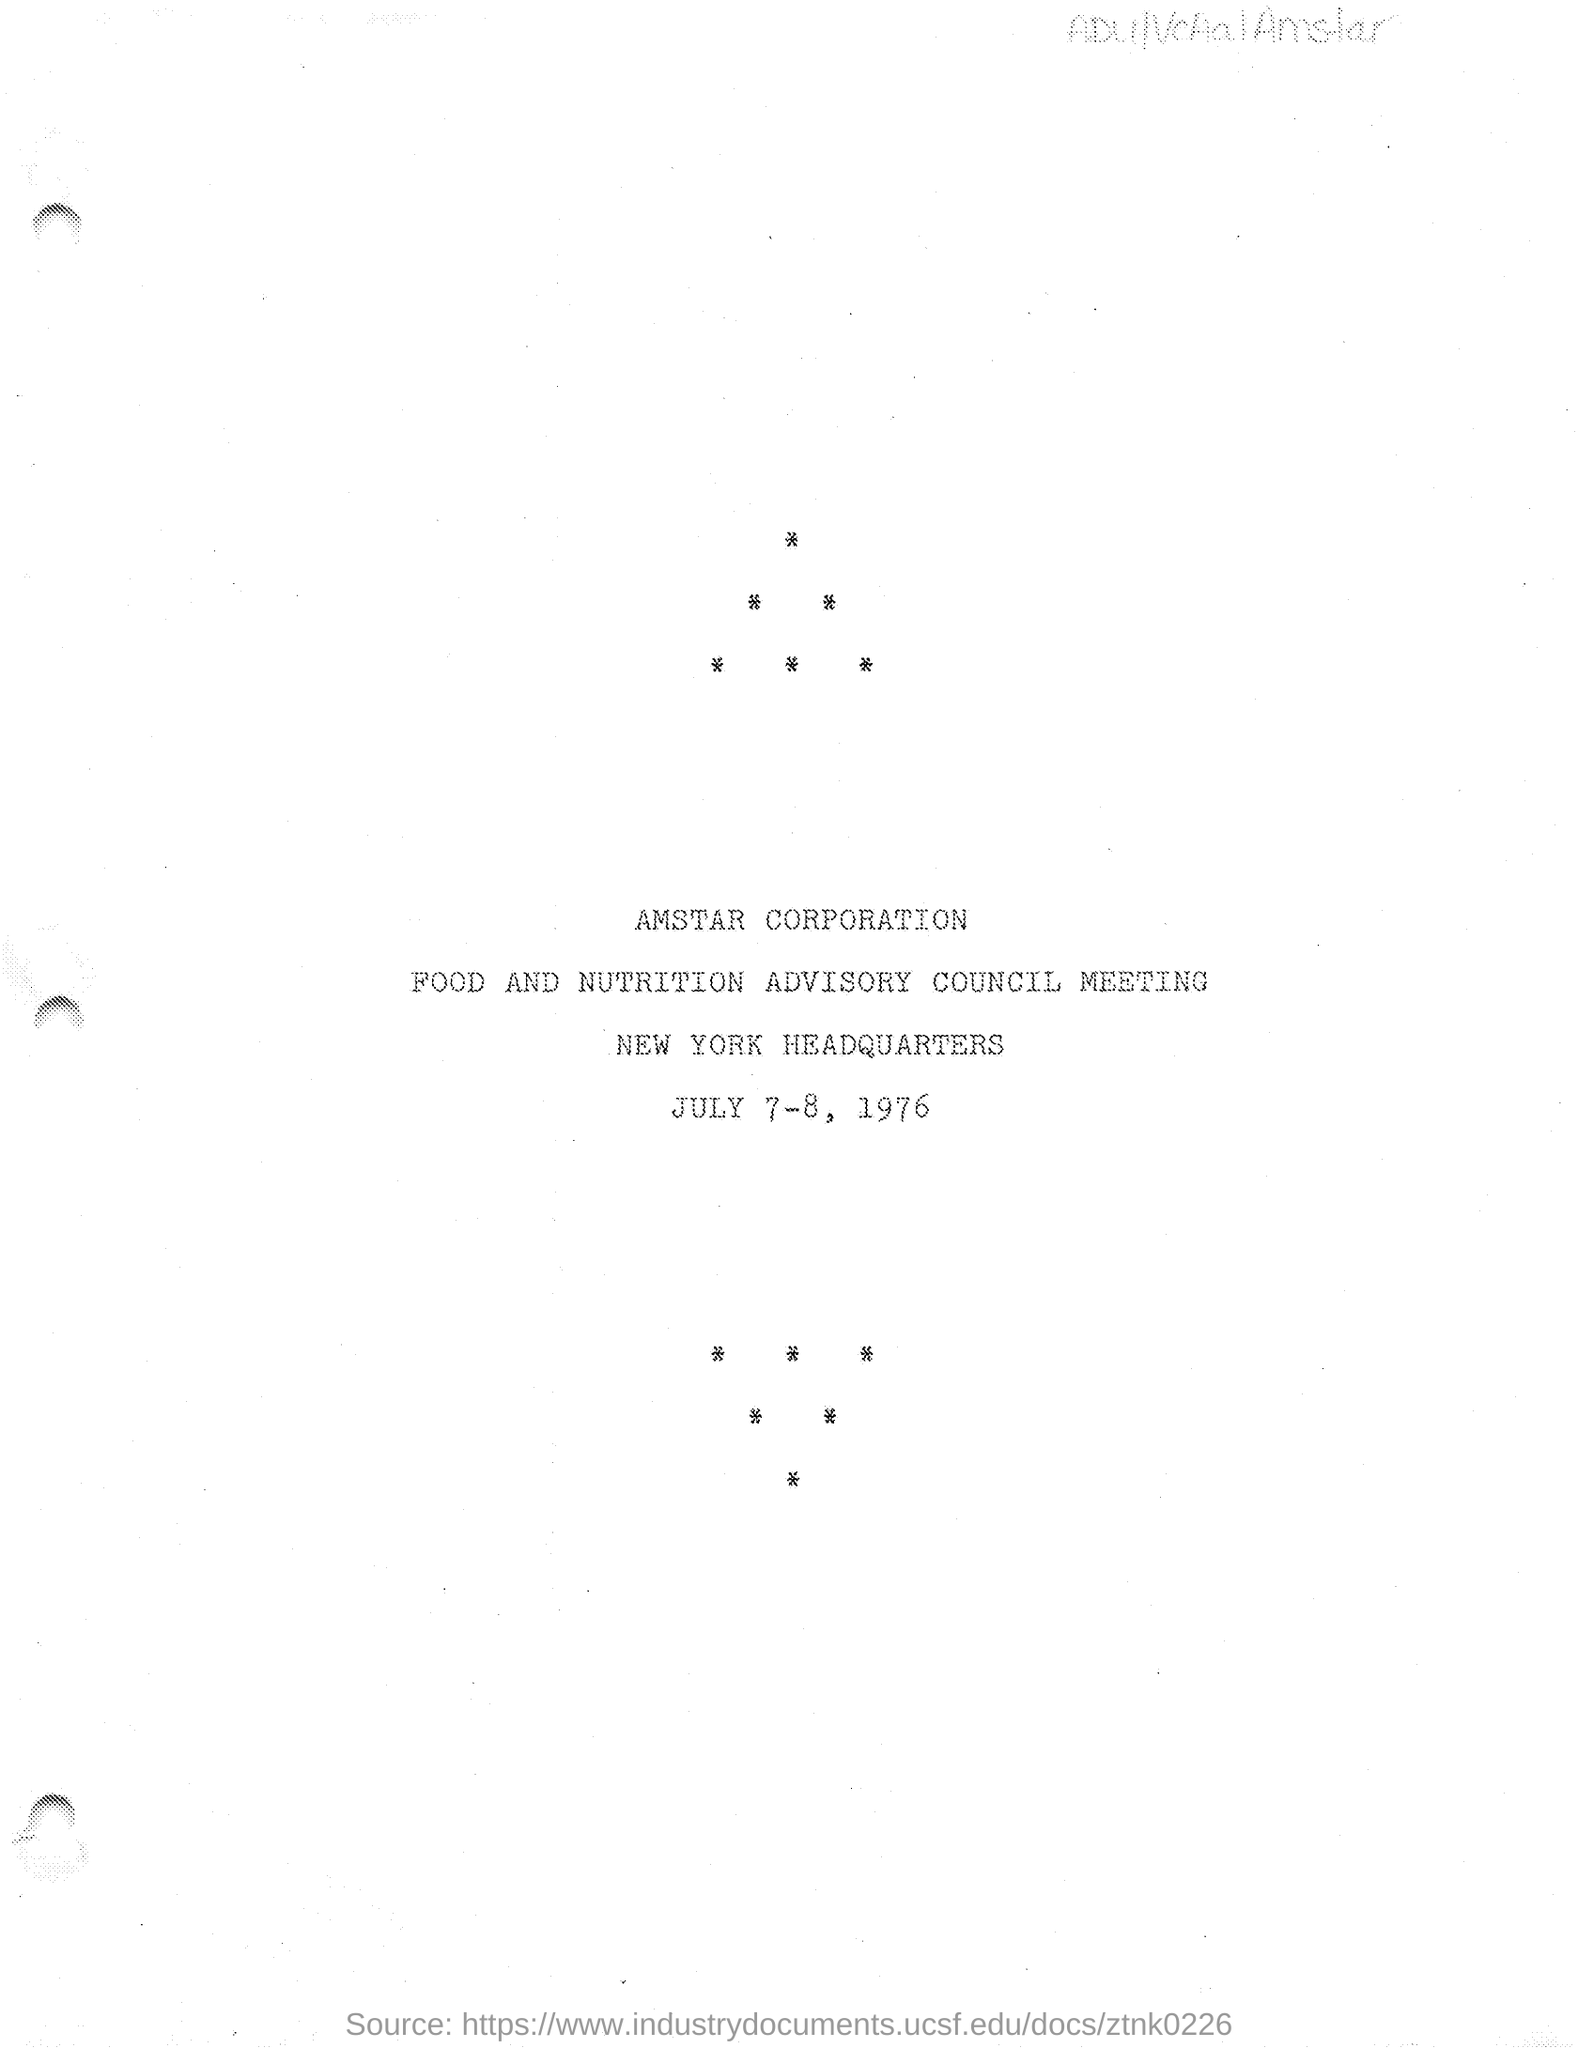What is the name of the corporation mentioned in the given page ?
Your answer should be very brief. Amstar corporation. What is the name of the meeting
Your response must be concise. Food and nutrition advisory council meeting. Where is the head quarters located as mentioned in the given page ?
Your answer should be very brief. New York Headquarters. What are the dates scheduled for the meeting as mentioned in the given page ?
Offer a very short reply. July 7-8 , 1976. 